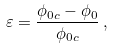<formula> <loc_0><loc_0><loc_500><loc_500>\varepsilon = \frac { \phi _ { 0 c } - \phi _ { 0 } } { \phi _ { 0 c } } \, ,</formula> 